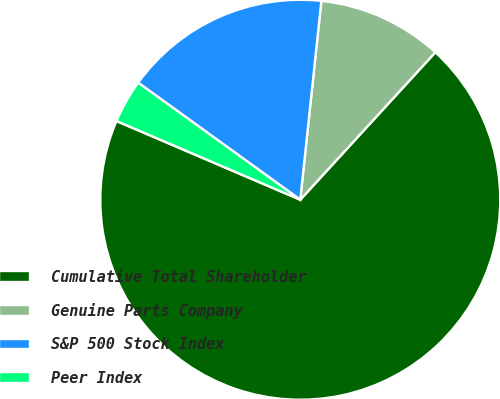Convert chart to OTSL. <chart><loc_0><loc_0><loc_500><loc_500><pie_chart><fcel>Cumulative Total Shareholder<fcel>Genuine Parts Company<fcel>S&P 500 Stock Index<fcel>Peer Index<nl><fcel>69.64%<fcel>10.12%<fcel>16.73%<fcel>3.51%<nl></chart> 